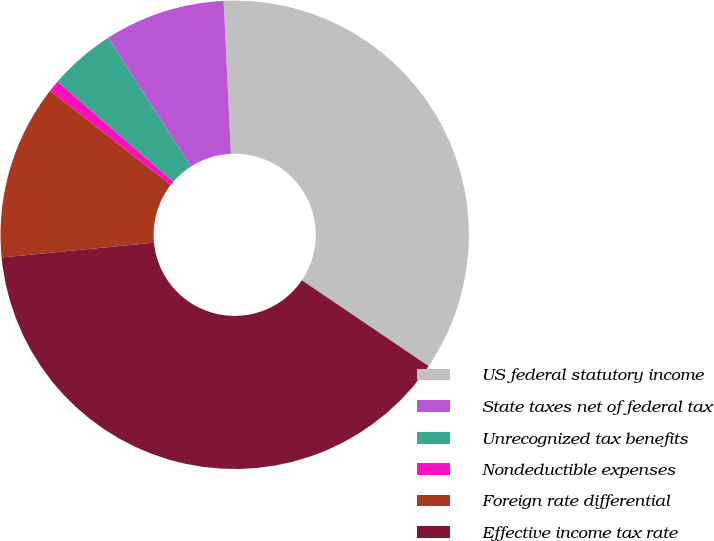<chart> <loc_0><loc_0><loc_500><loc_500><pie_chart><fcel>US federal statutory income<fcel>State taxes net of federal tax<fcel>Unrecognized tax benefits<fcel>Nondeductible expenses<fcel>Foreign rate differential<fcel>Effective income tax rate<nl><fcel>35.22%<fcel>8.33%<fcel>4.57%<fcel>0.8%<fcel>12.09%<fcel>38.98%<nl></chart> 